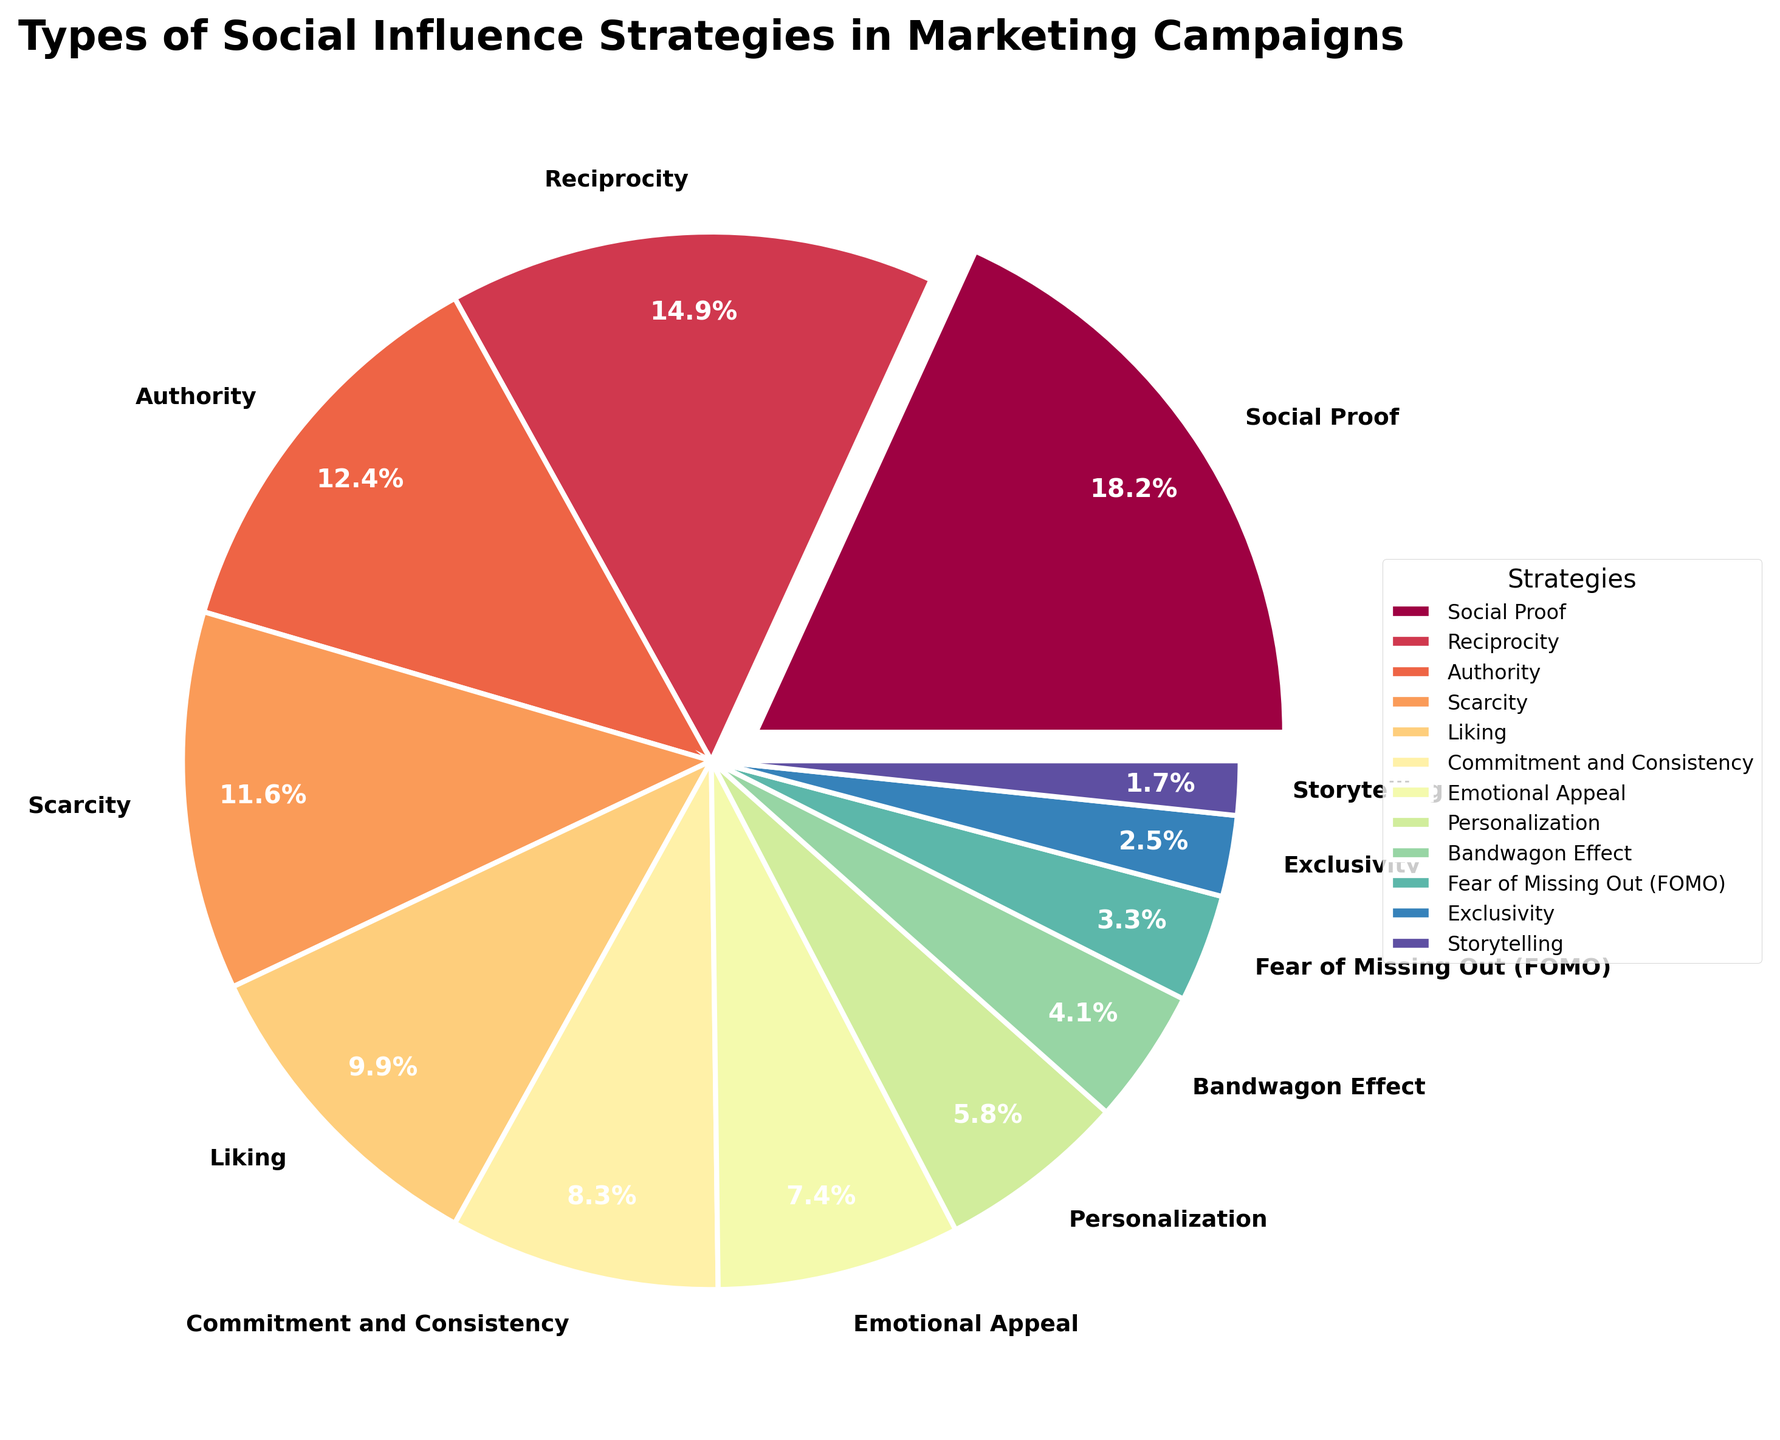What is the most commonly used social influence strategy in marketing campaigns? To find the answer, refer to the largest slice of the pie chart. The slice corresponding to 'Social Proof' is the largest.
Answer: Social Proof What is the combined percentage of Authority and Scarcity? Look at the pie chart slices labeled 'Authority' and 'Scarcity', which are 15% and 14% respectively. Add these percentages: 15 + 14 = 29.
Answer: 29% Which strategy is more commonly used: Liking or Commitment and Consistency? Compare the sizes of the pie chart slices labeled 'Liking' and 'Commitment and Consistency'. 'Liking' is 12% and 'Commitment and Consistency' is 10%. Thus, 'Liking' is larger.
Answer: Liking How much larger is Reciprocity compared to Emotional Appeal? Look at the slices labeled 'Reciprocity' and 'Emotional Appeal', which are 18% and 9% respectively. Subtract the smaller percentage from the larger one: 18 - 9 = 9.
Answer: 9% If Emotional Appeal and Personalization were combined into one category, what would be the new percentage? Add the percentages of 'Emotional Appeal' and 'Personalization': 9 + 7 = 16.
Answer: 16% Which strategy has the smallest percentage representation in the marketing campaigns? Identify the smallest slice in the pie chart. The slice labeled 'Storytelling' is the smallest at 2%.
Answer: Storytelling Is Bandwagon Effect more or less used than Fear of Missing Out (FOMO)? Compare the slices labeled 'Bandwagon Effect' and 'Fear of Missing Out (FOMO)'. 'Bandwagon Effect' is 5% and 'Fear of Missing Out (FOMO)' is 4%. Therefore, 'Bandwagon Effect' is used more.
Answer: More What is the total percentage for strategies under 10%? Identify strategies with percentages under 10%: 'Emotional Appeal' (9%), 'Personalization' (7%), 'Bandwagon Effect' (5%), 'Fear of Missing Out (FOMO)' (4%), 'Exclusivity' (3%), and 'Storytelling' (2%). Sum them: 9 + 7 + 5 + 4 + 3 + 2 = 30.
Answer: 30% Which strategy has a percentage closest to the median value of all given strategies? List all strategies' percentages: [22, 18, 15, 14, 12, 10, 9, 7, 5, 4, 3, 2]. The median is the average of the 6th and 7th values: (10 + 9) / 2 = 9.5. The closest strategy is 'Emotional Appeal' at 9%.
Answer: Emotional Appeal How does the appearance of the slice for Social Proof differ visually from the others? Notice the unique visual attributes of the 'Social Proof' slice. It is "exploded" or separated slightly from the rest of the pie, distinguishing it visually.
Answer: Exploded Slice 